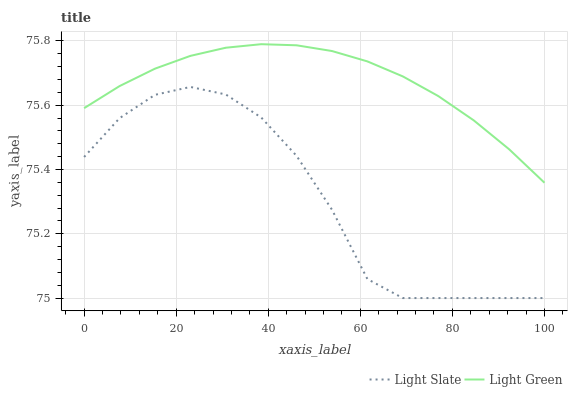Does Light Green have the minimum area under the curve?
Answer yes or no. No. Is Light Green the roughest?
Answer yes or no. No. Does Light Green have the lowest value?
Answer yes or no. No. Is Light Slate less than Light Green?
Answer yes or no. Yes. Is Light Green greater than Light Slate?
Answer yes or no. Yes. Does Light Slate intersect Light Green?
Answer yes or no. No. 